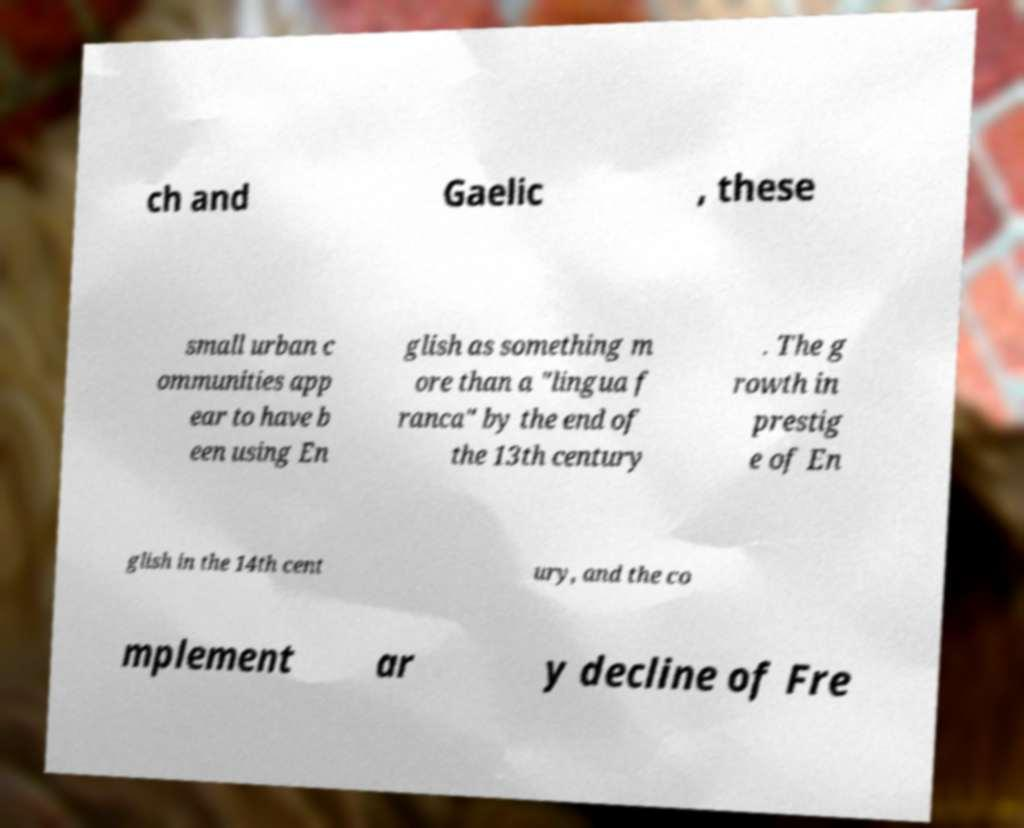Could you assist in decoding the text presented in this image and type it out clearly? ch and Gaelic , these small urban c ommunities app ear to have b een using En glish as something m ore than a "lingua f ranca" by the end of the 13th century . The g rowth in prestig e of En glish in the 14th cent ury, and the co mplement ar y decline of Fre 